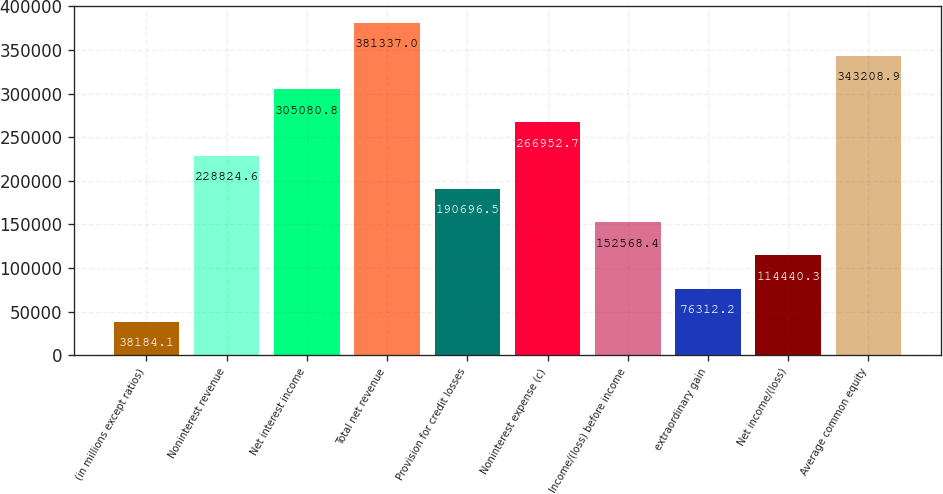Convert chart. <chart><loc_0><loc_0><loc_500><loc_500><bar_chart><fcel>(in millions except ratios)<fcel>Noninterest revenue<fcel>Net interest income<fcel>Total net revenue<fcel>Provision for credit losses<fcel>Noninterest expense (c)<fcel>Income/(loss) before income<fcel>extraordinary gain<fcel>Net income/(loss)<fcel>Average common equity<nl><fcel>38184.1<fcel>228825<fcel>305081<fcel>381337<fcel>190696<fcel>266953<fcel>152568<fcel>76312.2<fcel>114440<fcel>343209<nl></chart> 